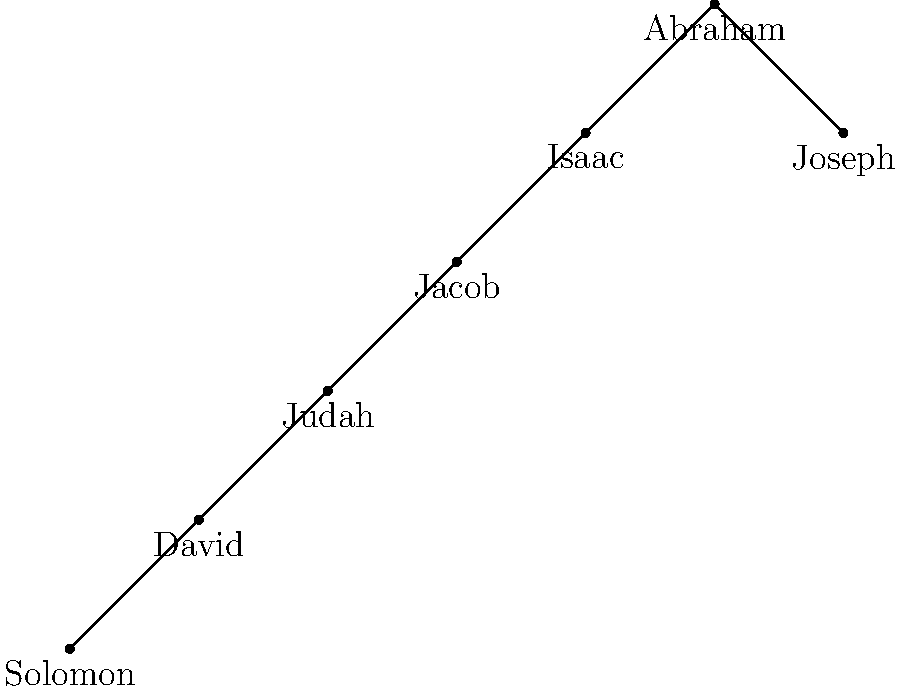Based on the family tree chart, which figure is considered the father of both the Israelite and Arab nations, and is a crucial ancestor in the lineage of Jesus Christ? To answer this question, let's examine the family tree chart step-by-step:

1. The chart shows a lineage starting from Abraham at the top.
2. Abraham has two direct descendants: Isaac and Joseph.
3. Isaac's line continues through Jacob, Judah, David, and Solomon.
4. This lineage represents the Israelite nation and the line of Jesus Christ.
5. Joseph's line, separate from Isaac's, represents the Arab nations.
6. Abraham is the common ancestor for both lines.
7. In Biblical history, Abraham is known as the father of both the Israelites (through Isaac) and the Arabs (through Ishmael, represented here by Joseph).
8. Abraham is also a crucial figure in the genealogy of Jesus Christ, as shown by the line descending to Solomon.

Therefore, Abraham is the figure who is considered the father of both the Israelite and Arab nations, and is a crucial ancestor in the lineage of Jesus Christ.
Answer: Abraham 